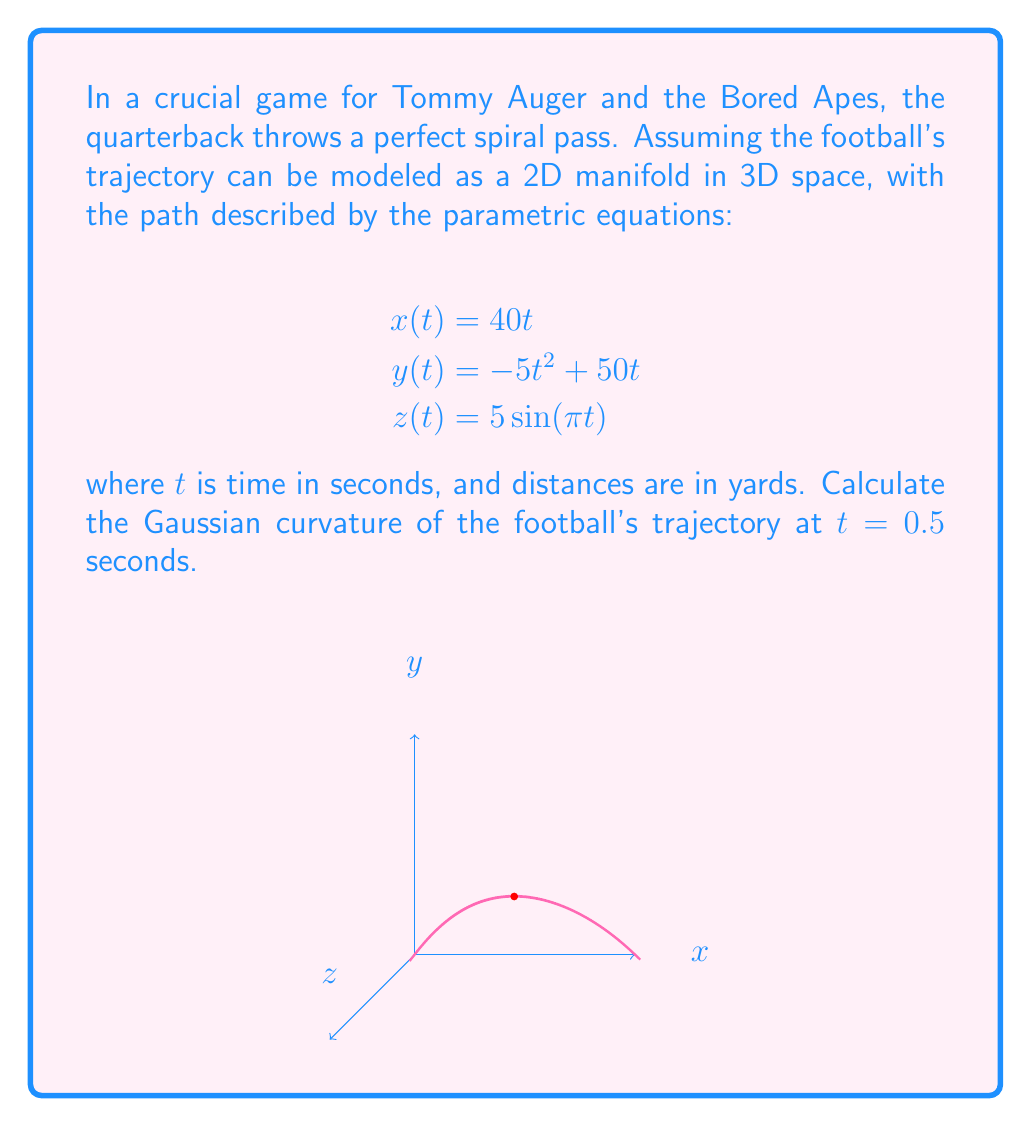What is the answer to this math problem? To calculate the Gaussian curvature, we need to follow these steps:

1) First, we need to calculate the first and second derivatives of x(t), y(t), and z(t):

   $$x'(t) = 40, x''(t) = 0$$
   $$y'(t) = -10t + 50, y''(t) = -10$$
   $$z'(t) = 5\pi\cos(\pi t), z''(t) = -5\pi^2\sin(\pi t)$$

2) Next, we calculate the first fundamental form coefficients:

   $$E = (x')^2 + (y')^2 + (z')^2$$
   $$F = x'x'' + y'y'' + z'z''$$
   $$G = (x'')^2 + (y'')^2 + (z'')^2$$

3) Then, we calculate the second fundamental form coefficients:

   $$L = \frac{x'y''z' - x'z''y' + y'z''x' - y'x''z' + z'x''y' - z'y''x'}{\sqrt{EG-F^2}}$$
   $$M = \frac{x''y''z' - x''z''y' + y''z''x' - y''x''z' + z''x''y' - z''y''x'}{\sqrt{EG-F^2}}$$
   $$N = \frac{x''y''z'' - x''(z'')^2 + y''(z'')^2 - y''(x'')^2 + z''(x'')^2 - z''(y'')^2}{\sqrt{EG-F^2}}$$

4) Finally, we calculate the Gaussian curvature:

   $$K = \frac{LN - M^2}{EG - F^2}$$

5) Evaluating at t = 0.5:

   $$x'(0.5) = 40, x''(0.5) = 0$$
   $$y'(0.5) = 45, y''(0.5) = -10$$
   $$z'(0.5) = 0, z''(0.5) = -5\pi^2$$

   $$E = 40^2 + 45^2 + 0^2 = 3625$$
   $$F = 40(0) + 45(-10) + 0(-5\pi^2) = -450$$
   $$G = 0^2 + (-10)^2 + (-5\pi^2)^2 = 246.7392$$

   $$L = \frac{40(-10)(0) - 40(-5\pi^2)(45) + 45(-5\pi^2)(40) - 45(0)(0) + 0(0)(45) - 0(-10)(40)}{\sqrt{3625(246.7392) - (-450)^2}} = 0$$

   $$M = \frac{0(-10)(0) - 0(-5\pi^2)(45) + (-10)(-5\pi^2)(40) - (-10)(0)(0) + (-5\pi^2)(0)(45) - (-5\pi^2)(-10)(40)}{\sqrt{3625(246.7392) - (-450)^2}} = -0.0403$$

   $$N = \frac{0(-10)(-5\pi^2) - 0(-5\pi^2)^2 + (-10)(-5\pi^2)^2 - (-10)(0)^2 + (-5\pi^2)(0)^2 - (-5\pi^2)(-10)^2}{\sqrt{3625(246.7392) - (-450)^2}} = -0.0064$$

   $$K = \frac{(0)(-0.0064) - (-0.0403)^2}{3625(246.7392) - (-450)^2} = -1.8090 \times 10^{-6}$$
Answer: $-1.8090 \times 10^{-6}$ yd$^{-2}$ 